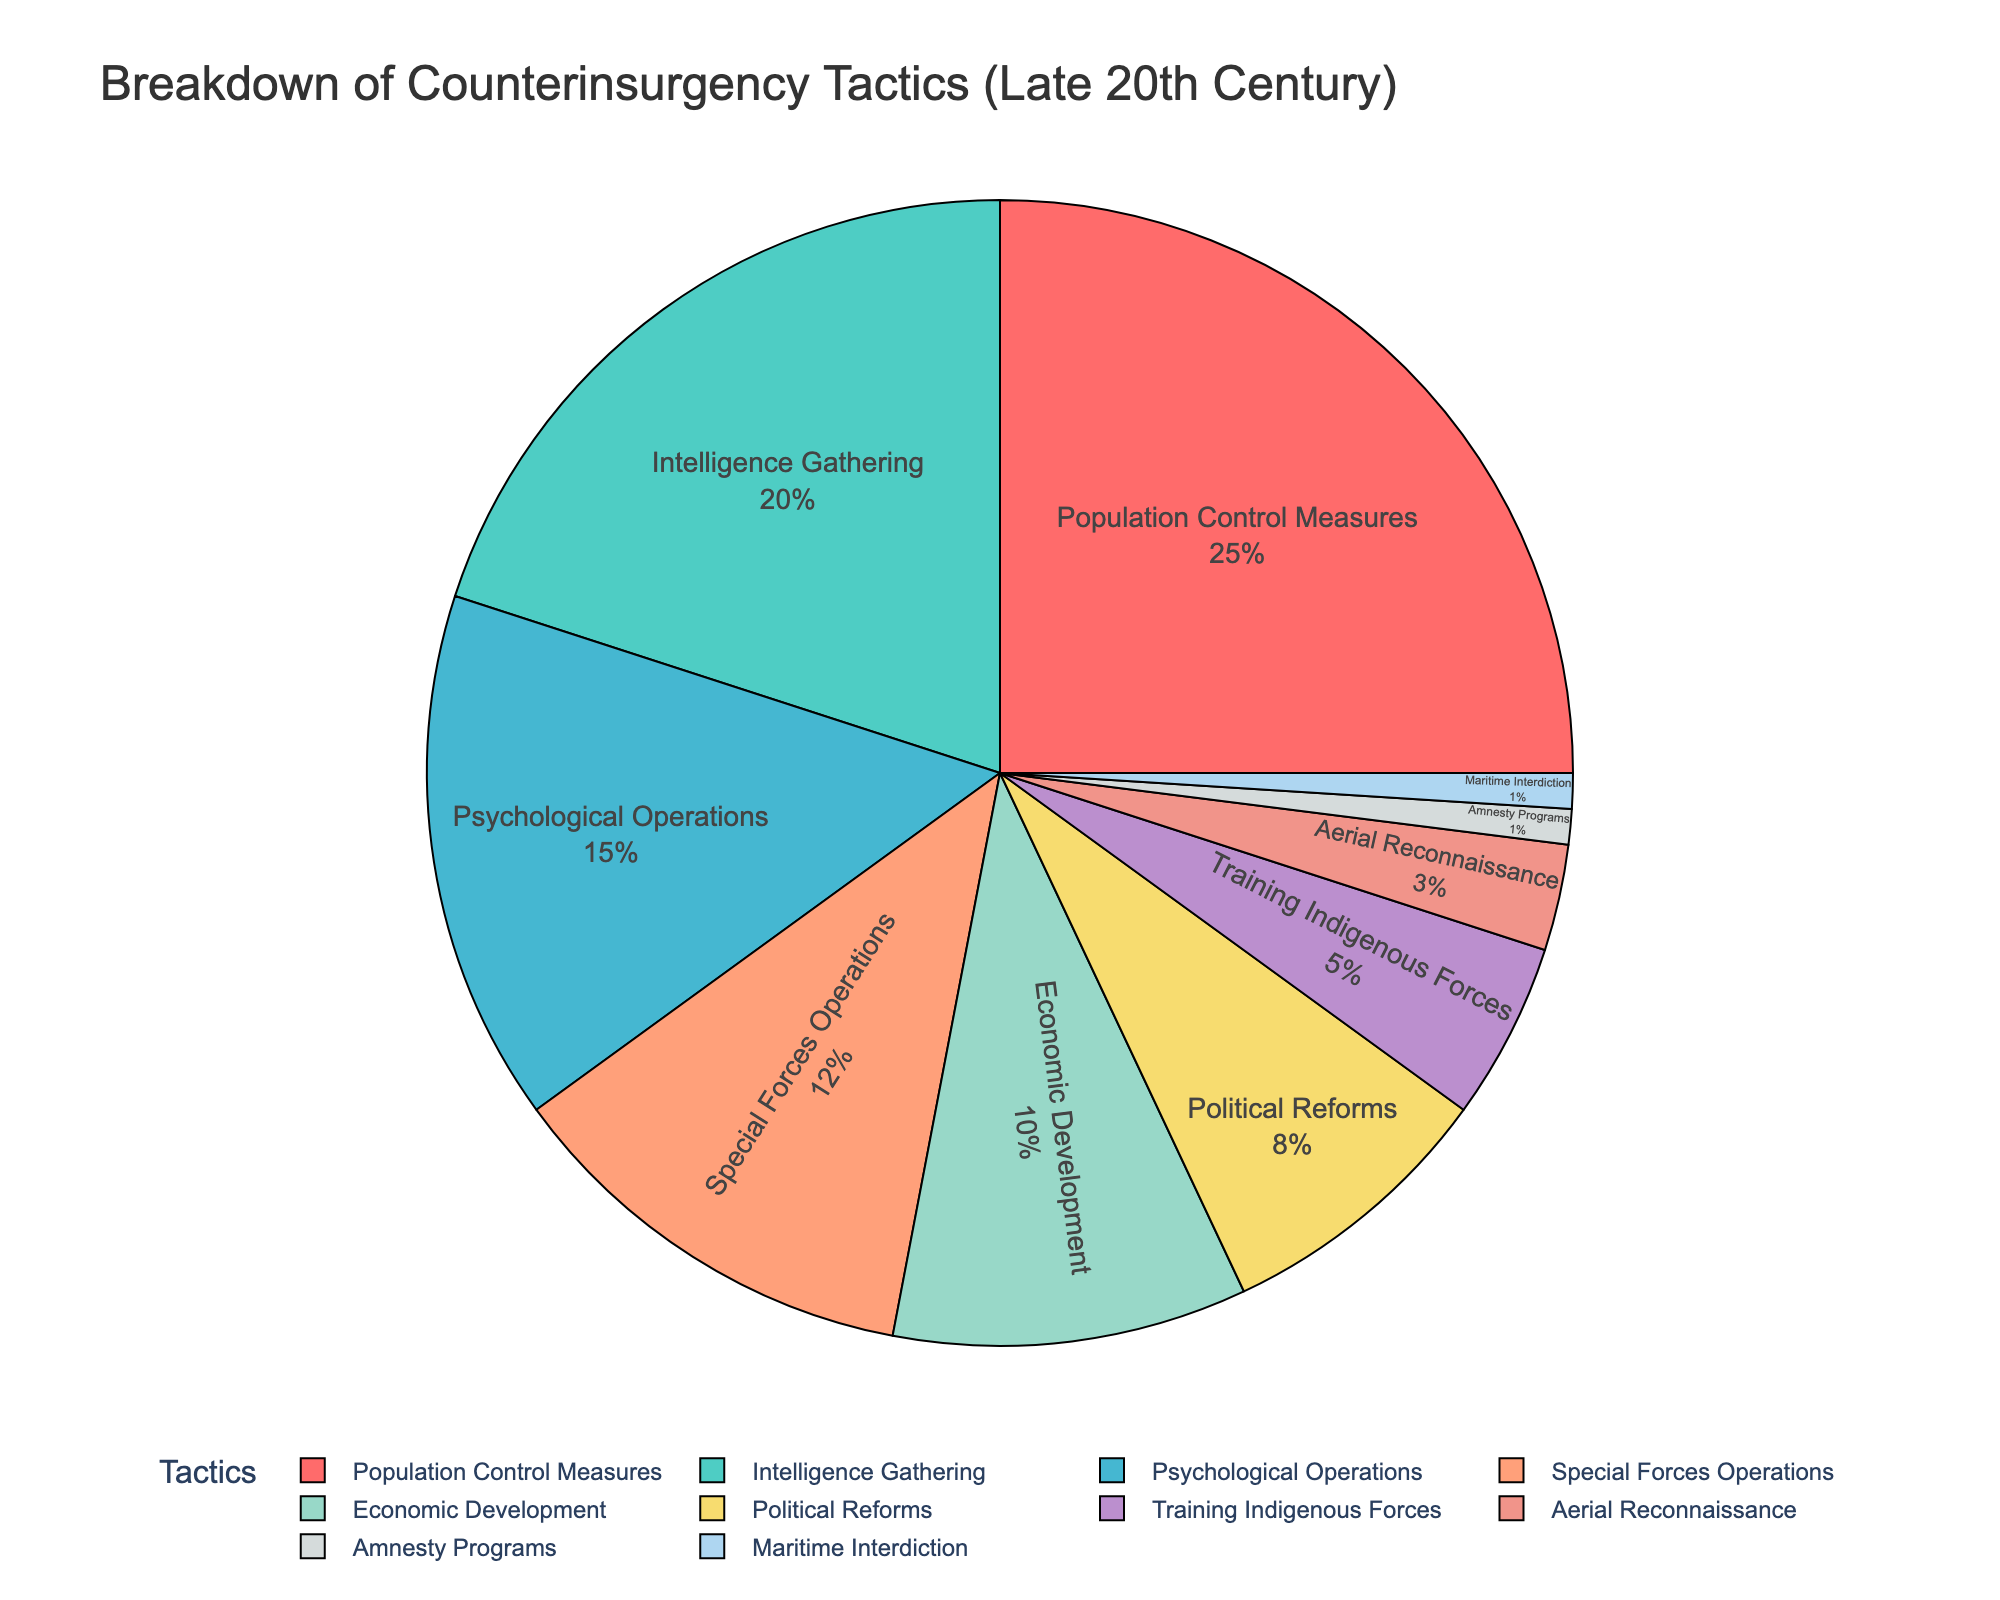What's the most employed counterinsurgency tactic in the late 20th century? The pie chart shows that the largest segment corresponds to Population Control Measures. This implies it is the most commonly used tactic.
Answer: Population Control Measures What's the least employed counterinsurgency tactic? According to the pie chart, Amnesty Programs and Maritime Interdiction share the smallest percentage as they each occupy the smallest segment.
Answer: Amnesty Programs and Maritime Interdiction How much more common are Special Forces Operations compared to Training Indigenous Forces? From the chart, Special Forces Operations constitute 12%, while Training Indigenous Forces account for 5%. Subtracting these values gives the difference.
Answer: 7% What is the combined percentage of Intelligence Gathering and Psychological Operations? Intelligence Gathering is 20% and Psychological Operations is 15%. Adding these together results in 35%.
Answer: 35% Which tactics occupy more than a quarter of the total tactics employed? The chart shows that only Population Control Measures has a percentage over 25%.
Answer: Population Control Measures Which tactics are two of the smallest categories? The chart indicates Amnesty Programs and Maritime Interdiction each constitute 1%, making them the smallest categories.
Answer: Amnesty Programs and Maritime Interdiction Compare the percentage use of Economic Development and Political Reforms. Which is higher and by how much? Economic Development is 10% and Political Reforms is 8%. Subtracting these, Economic Development is 2% higher.
Answer: Economic Development by 2% What's the total percentage of Population Control Measures, Special Forces Operations, and Economic Development combined? Adding Population Control Measures (25%), Special Forces Operations (12%), and Economic Development (10%) together results in 47%.
Answer: 47% Which segment is represented by the green slice in the pie chart? The green slice corresponds to Intelligence Gathering.
Answer: Intelligence Gathering Which tactic is represented by a blue slice, and what percentage does it hold? The blue slice represents Special Forces Operations and it holds a percentage of 12%.
Answer: Special Forces Operations, 12% 